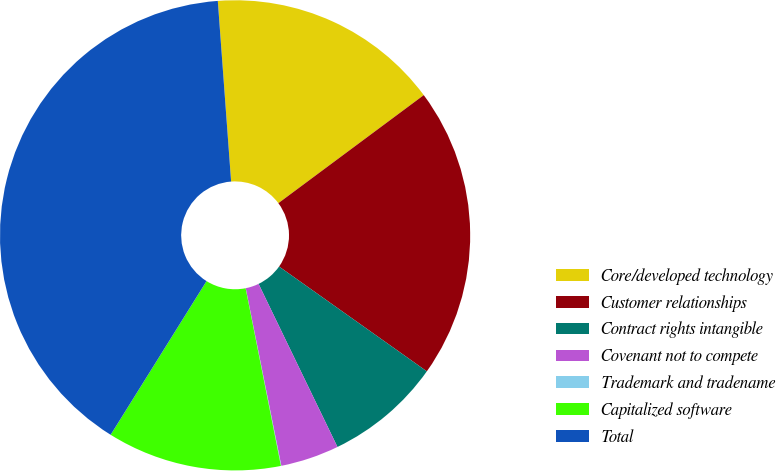Convert chart. <chart><loc_0><loc_0><loc_500><loc_500><pie_chart><fcel>Core/developed technology<fcel>Customer relationships<fcel>Contract rights intangible<fcel>Covenant not to compete<fcel>Trademark and tradename<fcel>Capitalized software<fcel>Total<nl><fcel>16.0%<fcel>19.99%<fcel>8.01%<fcel>4.02%<fcel>0.03%<fcel>12.0%<fcel>39.95%<nl></chart> 